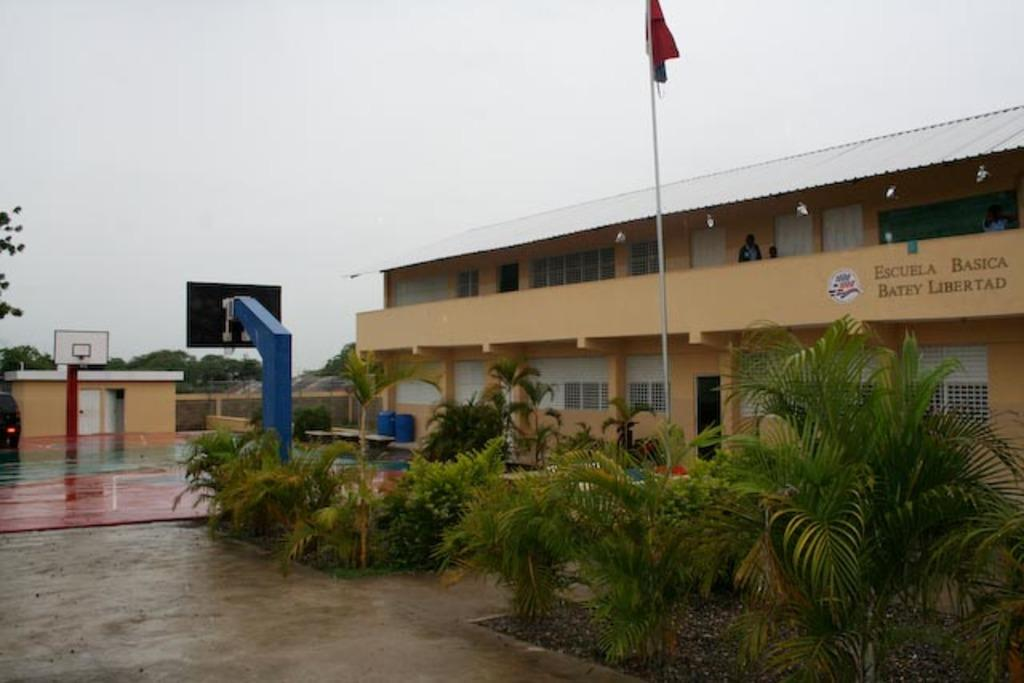What type of structure is visible in the image? There is a building in the image. What is located in front of the building? There is a basketball court and plants in front of the building. Is there any symbol or emblem present in front of the building? Yes, there is a flag in front of the building. What color is the crayon used to draw the goat on the rule in the image? There is no crayon, goat, or rule present in the image. 